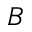<formula> <loc_0><loc_0><loc_500><loc_500>B</formula> 